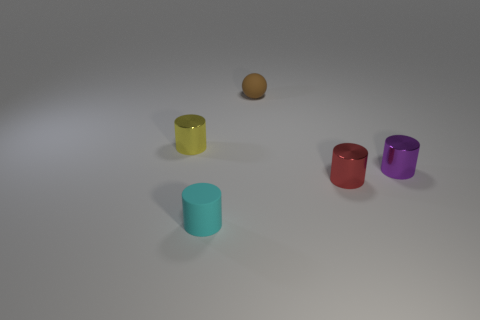Subtract all metal cylinders. How many cylinders are left? 1 Subtract all spheres. How many objects are left? 4 Subtract all purple cylinders. How many cylinders are left? 3 Add 2 tiny brown rubber things. How many tiny brown rubber things are left? 3 Add 5 tiny cylinders. How many tiny cylinders exist? 9 Add 5 large cyan cylinders. How many objects exist? 10 Subtract 1 purple cylinders. How many objects are left? 4 Subtract 1 spheres. How many spheres are left? 0 Subtract all purple cylinders. Subtract all yellow balls. How many cylinders are left? 3 Subtract all yellow cylinders. How many gray spheres are left? 0 